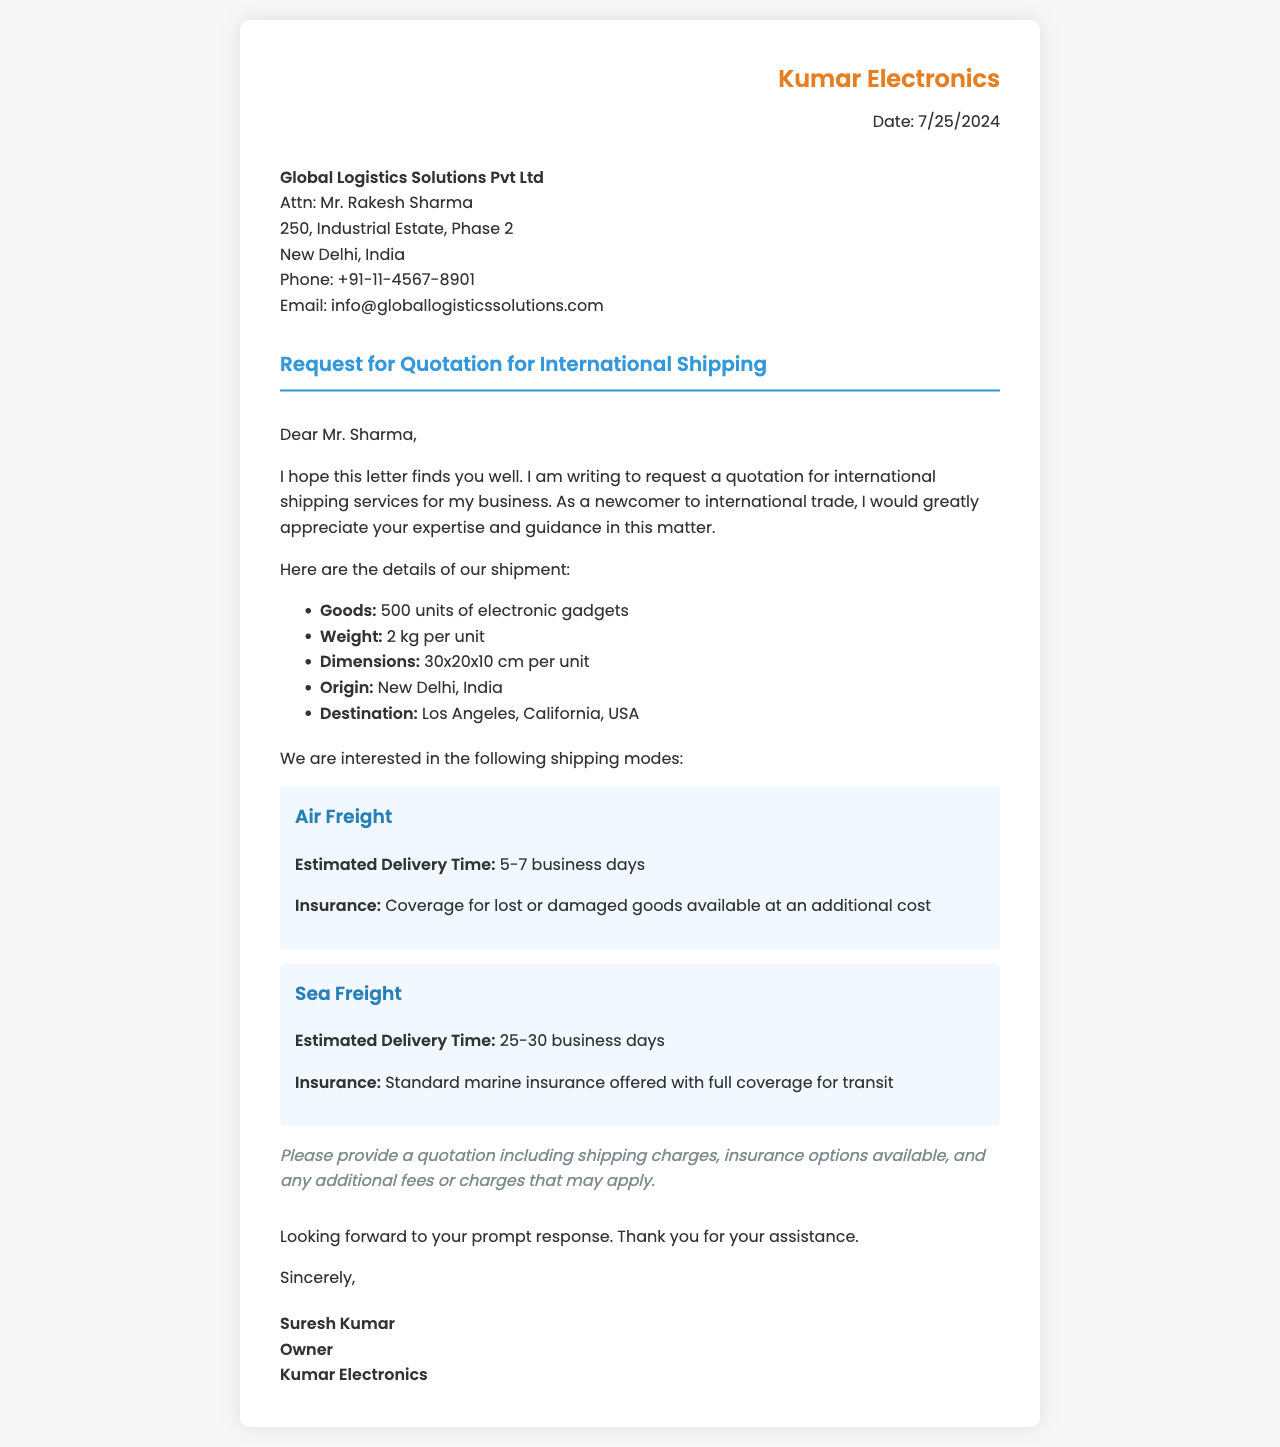What is the name of the company sending the request? The company sending the request is mentioned at the top of the letter as Kumar Electronics.
Answer: Kumar Electronics Who is the recipient of the letter? The recipient is introduced in the letter, specifying the company and the person to whom it is addressed.
Answer: Global Logistics Solutions Pvt Ltd How many units of electronic gadgets are being shipped? The document explicitly states the number of goods being shipped as part of the shipment details.
Answer: 500 units What is the estimated delivery time for Air Freight? The letter details the estimated delivery time specifically for Air Freight.
Answer: 5-7 business days What are the shipping modes listed in the document? The document mentions specific modes of shipping, which can be directly referred to in the inquiry section.
Answer: Air Freight, Sea Freight What is the weight of each unit being shipped? The letter provides a specific weight for the electronic gadgets, reflecting pertinent shipment details.
Answer: 2 kg per unit What is the destination of the shipment? The document clearly indicates the final destination for the goods being shipped.
Answer: Los Angeles, California, USA What type of insurance is offered with Sea Freight? The letter specifies the type of insurance available with the Sea Freight shipping mode.
Answer: Standard marine insurance What additional information is requested from the logistics company? The document includes a specific inquiry at the end regarding the information sought from the recipient.
Answer: Quotation including shipping charges, insurance options, additional fees 